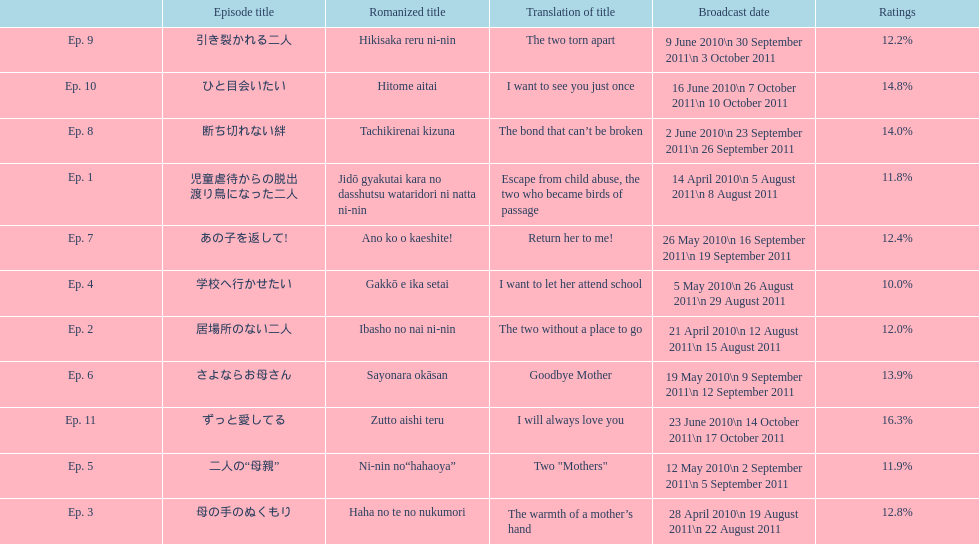Which episode was named "i want to let her go to school"? Ep. 4. 